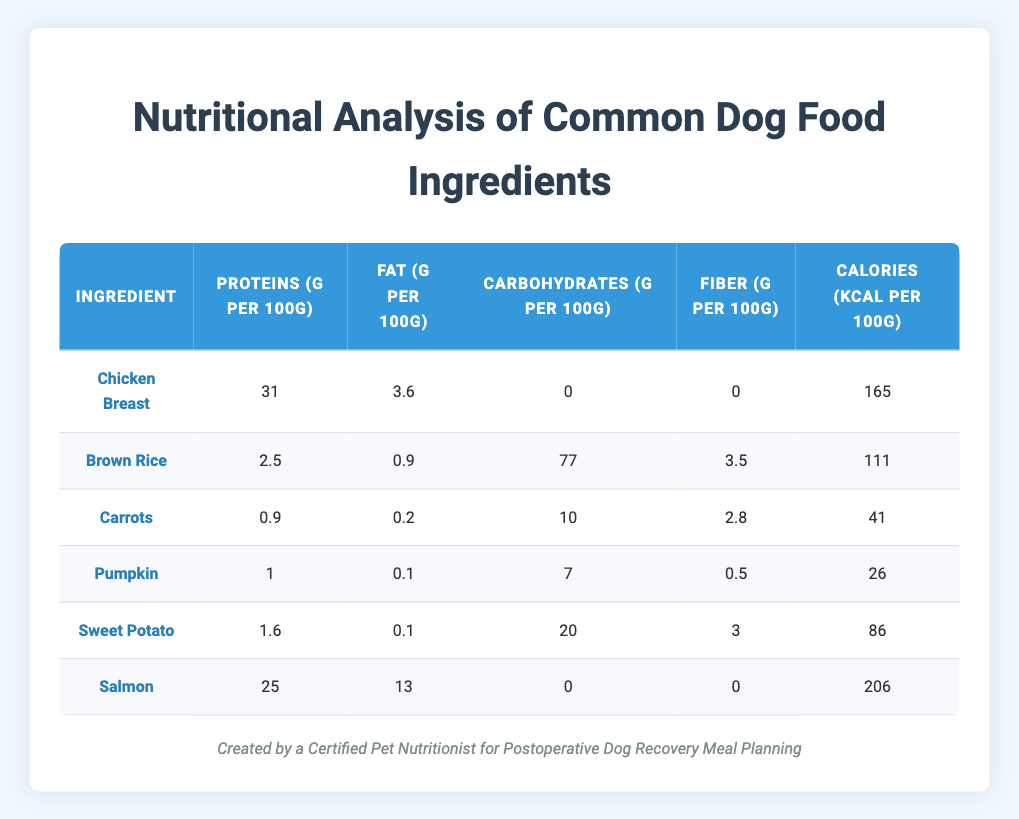What is the protein content in Chicken Breast? The table indicates that Chicken Breast contains 31 grams of protein per 100 grams.
Answer: 31 grams Which ingredient has the highest calorie count per 100 grams? By examining the calories column, Salmon has the highest calorie count with 206 Kcal per 100 grams.
Answer: Salmon How much protein do Salmon and Chicken Breast contain collectively? The protein content in Salmon is 25 grams and in Chicken Breast is 31 grams. Adding them together gives 25 + 31 = 56 grams of protein.
Answer: 56 grams Is the carbohydrate content in Sweet Potato greater than in Carrots? Sweet Potato has 20 grams of carbohydrates while Carrots have 10 grams. Since 20 is greater than 10, the statement is true.
Answer: Yes What is the average fat content of the ingredients listed? First, sum the fat contents: 3.6 (Chicken Breast) + 0.9 (Brown Rice) + 0.2 (Carrots) + 0.1 (Pumpkin) + 0.1 (Sweet Potato) + 13 (Salmon) = 18 grams. There are 6 ingredients, so the average is 18/6 = 3 grams.
Answer: 3 grams Which ingredient has the least amount of fiber per 100 grams? From the fiber column, Pumpkin has the least fiber at 0.5 grams.
Answer: Pumpkin Is the protein content in Brown Rice an average value compared to the other ingredients? Brown Rice has 2.5 grams of protein, which is less than the average protein content of the other ingredients (average excluding Brown Rice is ((31 + 0.9 + 1 + 1.6 + 25)/5) = 11.1 grams). Thus, 2.5 is below average.
Answer: Yes How much do Carrots and Pumpkin contribute to the total carbohydrate content together? The carbohydrate content is 10 grams for Carrots and 7 grams for Pumpkin. Adding them gives 10 + 7 = 17 grams of carbohydrates combined.
Answer: 17 grams 